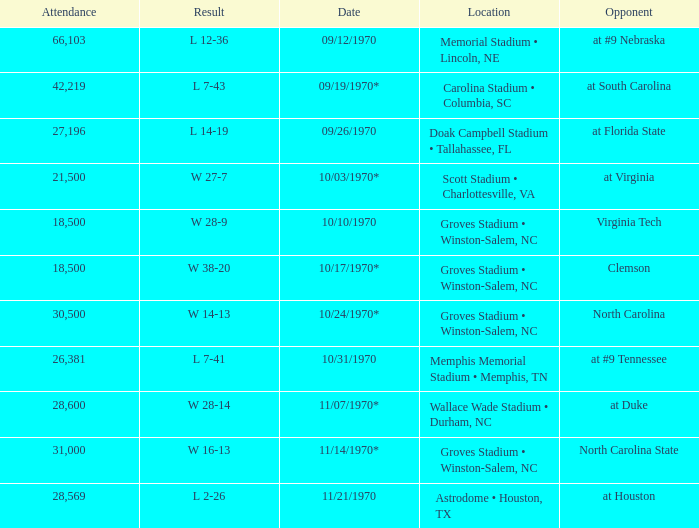How many people attended the game against Clemson? 1.0. 